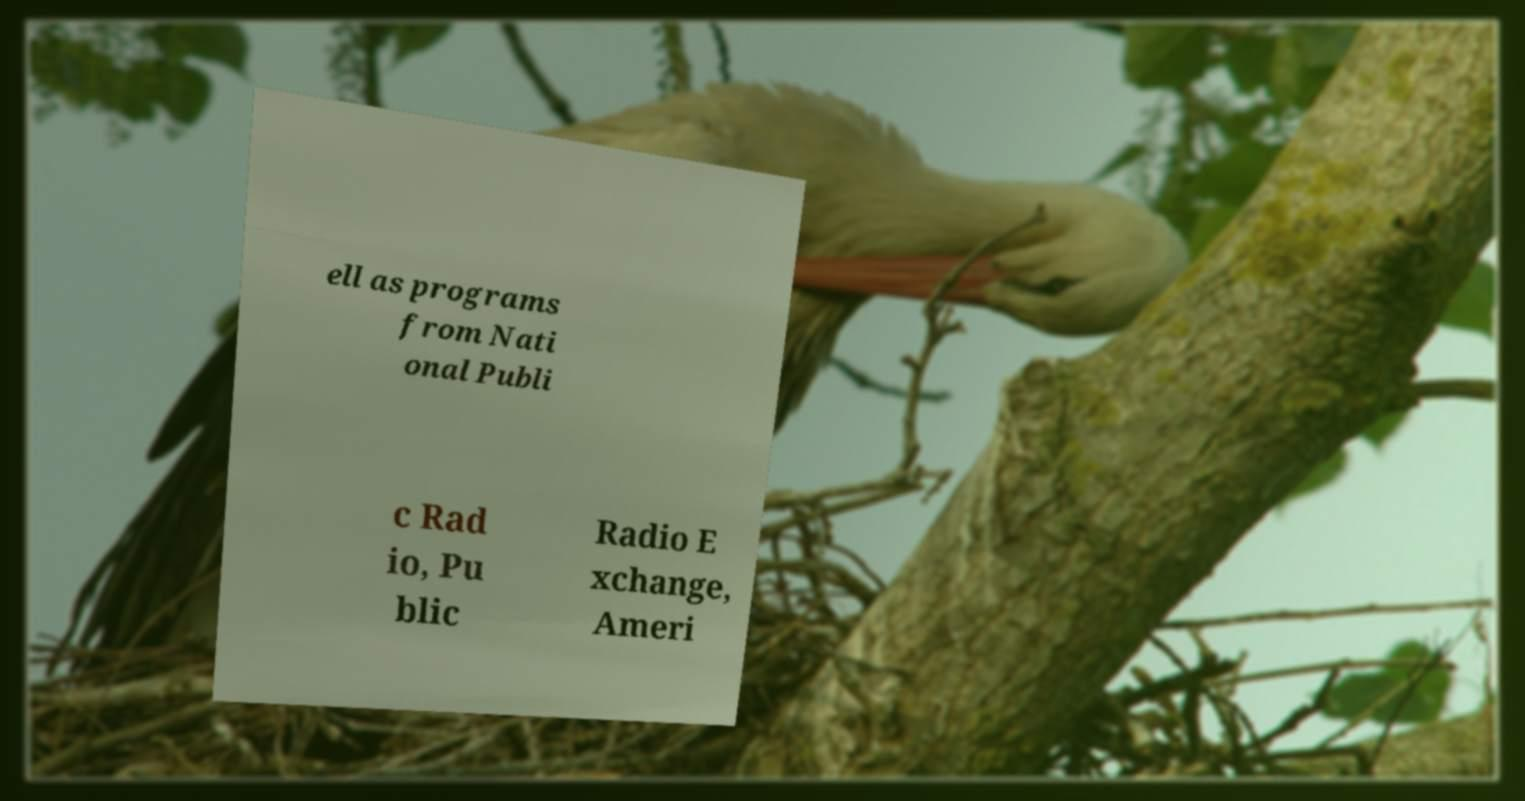Please identify and transcribe the text found in this image. ell as programs from Nati onal Publi c Rad io, Pu blic Radio E xchange, Ameri 